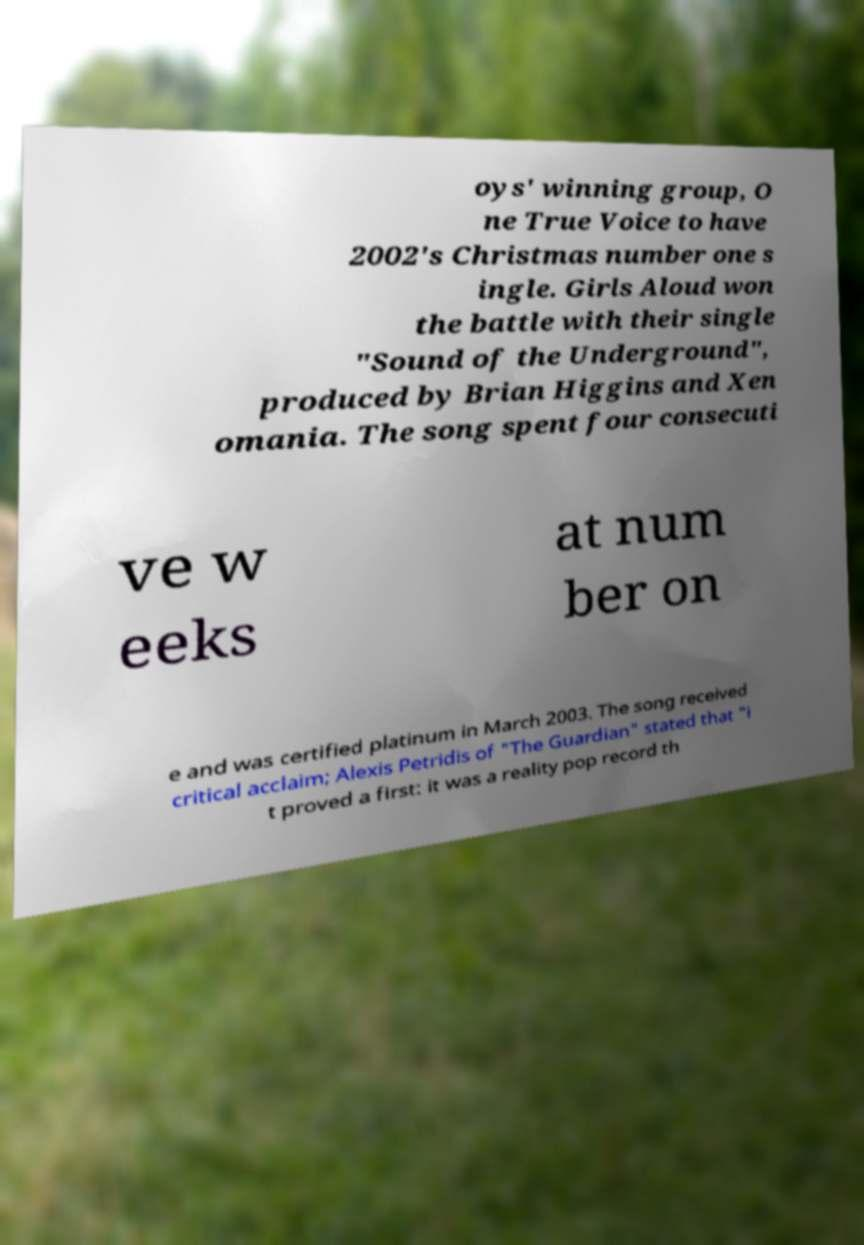I need the written content from this picture converted into text. Can you do that? oys' winning group, O ne True Voice to have 2002's Christmas number one s ingle. Girls Aloud won the battle with their single "Sound of the Underground", produced by Brian Higgins and Xen omania. The song spent four consecuti ve w eeks at num ber on e and was certified platinum in March 2003. The song received critical acclaim; Alexis Petridis of "The Guardian" stated that "i t proved a first: it was a reality pop record th 